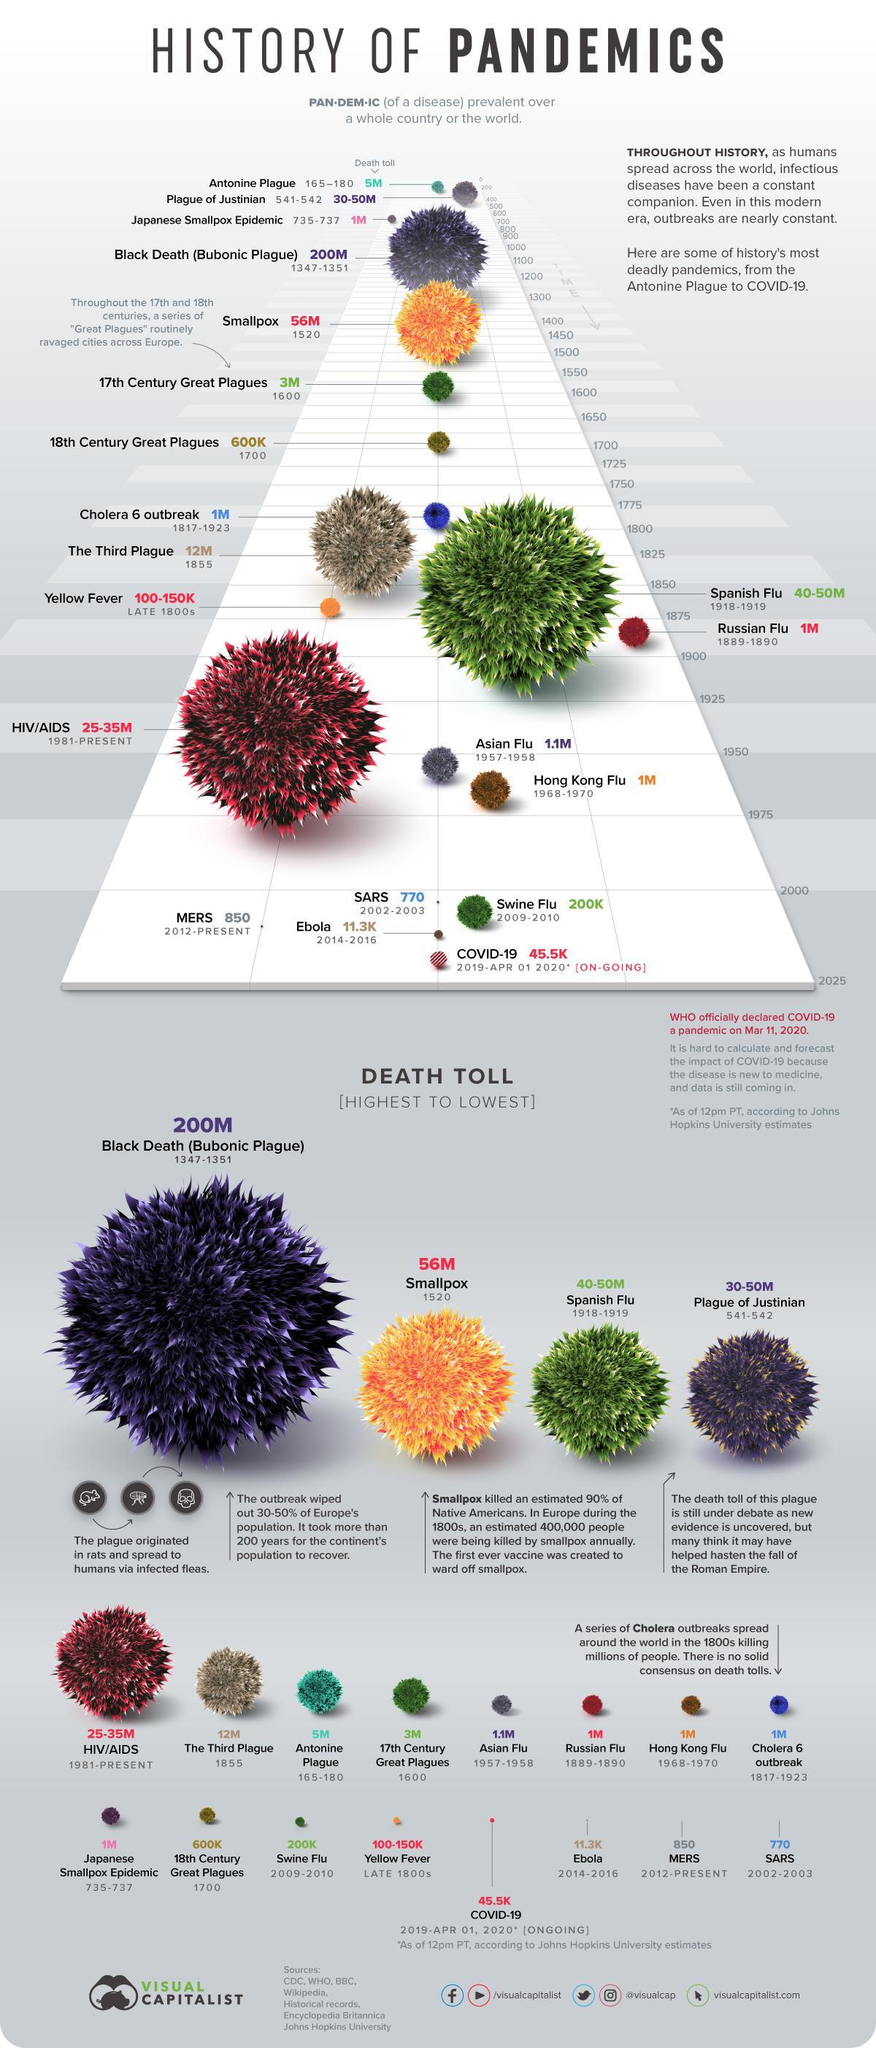During which time period, the swine flu outbreak happened?
Answer the question with a short phrase. 2009-2010 Which disease outbreak happened in 1520? Smallpox Which disease outbreak happened during 1968-1970? Hong Kong Flu During which time period, the Cholera 6 outbreak happened? 1817-1923 During which time period, the Asian flu pandemic happened? 1957-1958 How many people were killed by the Russian Flu? 1M How many people were killed by the Bubonic Plague? 200M Which disease outbreak happened in the late 1800s? Yellow Fever Which disease outbreak has killed 12 million people in 1855? The Third Plague How many people were killed by the smallpox disease? 56M 